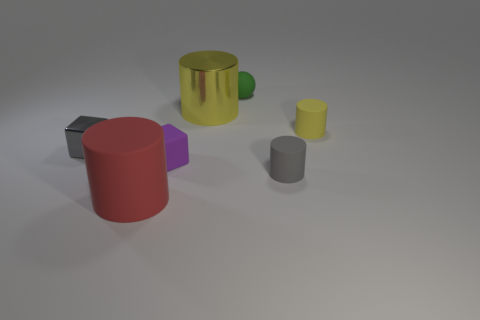Does the matte cube have the same color as the tiny matte sphere?
Provide a succinct answer. No. Is there any other thing of the same color as the small sphere?
Your answer should be compact. No. Is the shape of the large thing behind the small gray cube the same as the yellow object on the right side of the tiny green rubber object?
Your response must be concise. Yes. How many objects are big yellow things or matte objects behind the large red object?
Your response must be concise. 5. How many other objects are the same size as the gray metallic cube?
Your response must be concise. 4. Are the tiny block that is in front of the metal cube and the yellow cylinder left of the tiny green matte sphere made of the same material?
Give a very brief answer. No. There is a ball; what number of gray metal objects are on the right side of it?
Keep it short and to the point. 0. How many gray objects are small rubber cylinders or large metal cylinders?
Your answer should be compact. 1. What is the material of the other purple cube that is the same size as the shiny block?
Offer a very short reply. Rubber. What is the shape of the rubber thing that is on the left side of the yellow shiny object and to the right of the large matte cylinder?
Your response must be concise. Cube. 